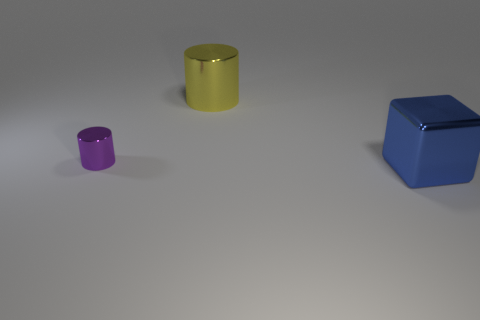Add 1 purple rubber balls. How many objects exist? 4 Subtract all cylinders. How many objects are left? 1 Subtract all metallic cubes. Subtract all blue objects. How many objects are left? 1 Add 3 tiny cylinders. How many tiny cylinders are left? 4 Add 1 blue objects. How many blue objects exist? 2 Subtract 0 purple blocks. How many objects are left? 3 